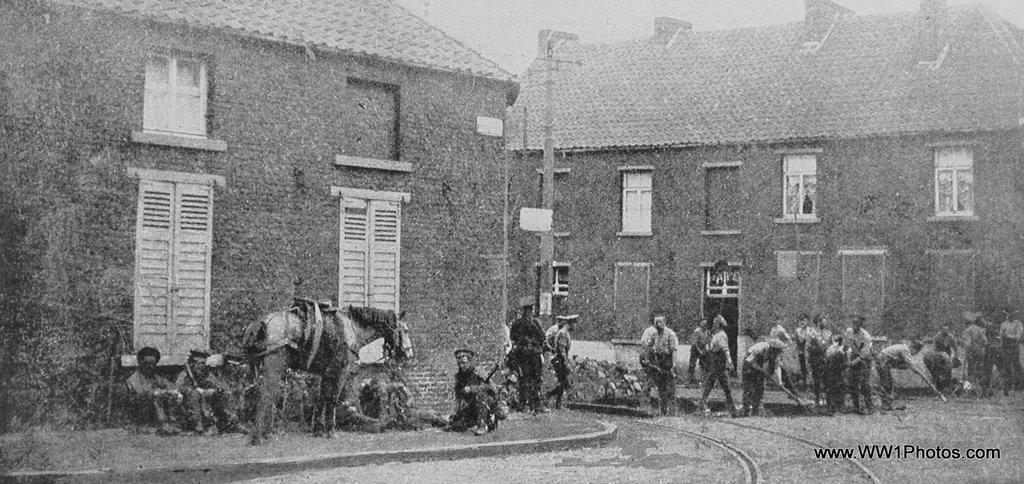How would you summarize this image in a sentence or two? This is a black and white image. There are people in the foreground of the image. There is a horse. In the background of the image there are houses. There are windows. There are doors. At the bottom of the image there is road. 